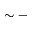Convert formula to latex. <formula><loc_0><loc_0><loc_500><loc_500>\sim -</formula> 